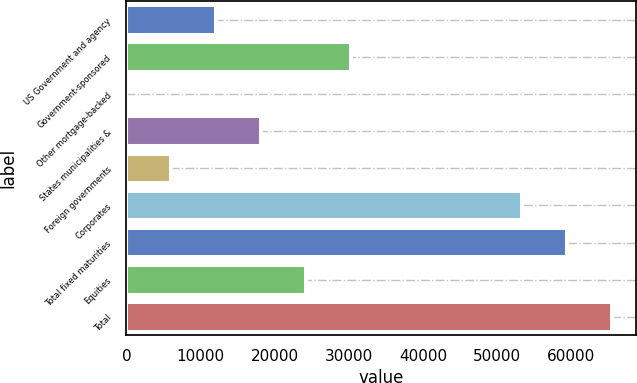Convert chart. <chart><loc_0><loc_0><loc_500><loc_500><bar_chart><fcel>US Government and agency<fcel>Government-sponsored<fcel>Other mortgage-backed<fcel>States municipalities &<fcel>Foreign governments<fcel>Corporates<fcel>Total fixed maturities<fcel>Equities<fcel>Total<nl><fcel>12146.6<fcel>30359.4<fcel>4.79<fcel>18217.5<fcel>6075.71<fcel>53349<fcel>59419.9<fcel>24288.5<fcel>65490.8<nl></chart> 